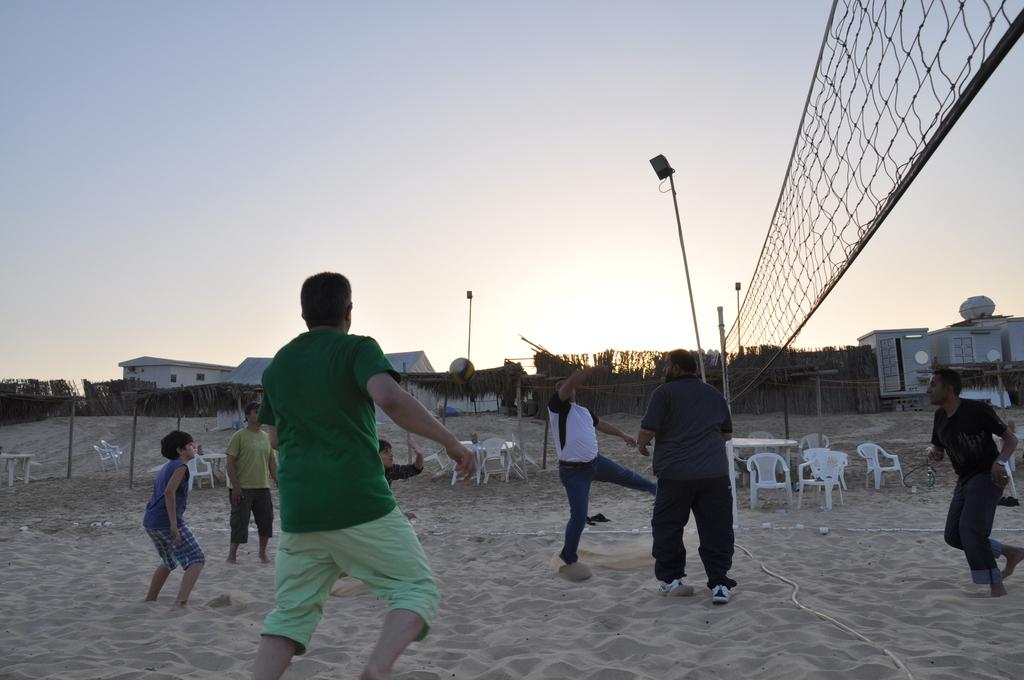What activity are the people in the image engaged in? The people in the image are playing volleyball. Where is the game taking place? The game is taking place on a ground. What can be seen in the background of the image? There are white chairs and small houses visible in the background. What is visible at the top of the image? The sky is visible at the top of the image. How many lizards are crawling on the volleyball net in the image? There are no lizards present in the image; the focus is on the people playing volleyball. What type of yoke is being used by the players to adjust their swings? There is no yoke present in the image, and the players are not using any equipment to adjust their swings. 